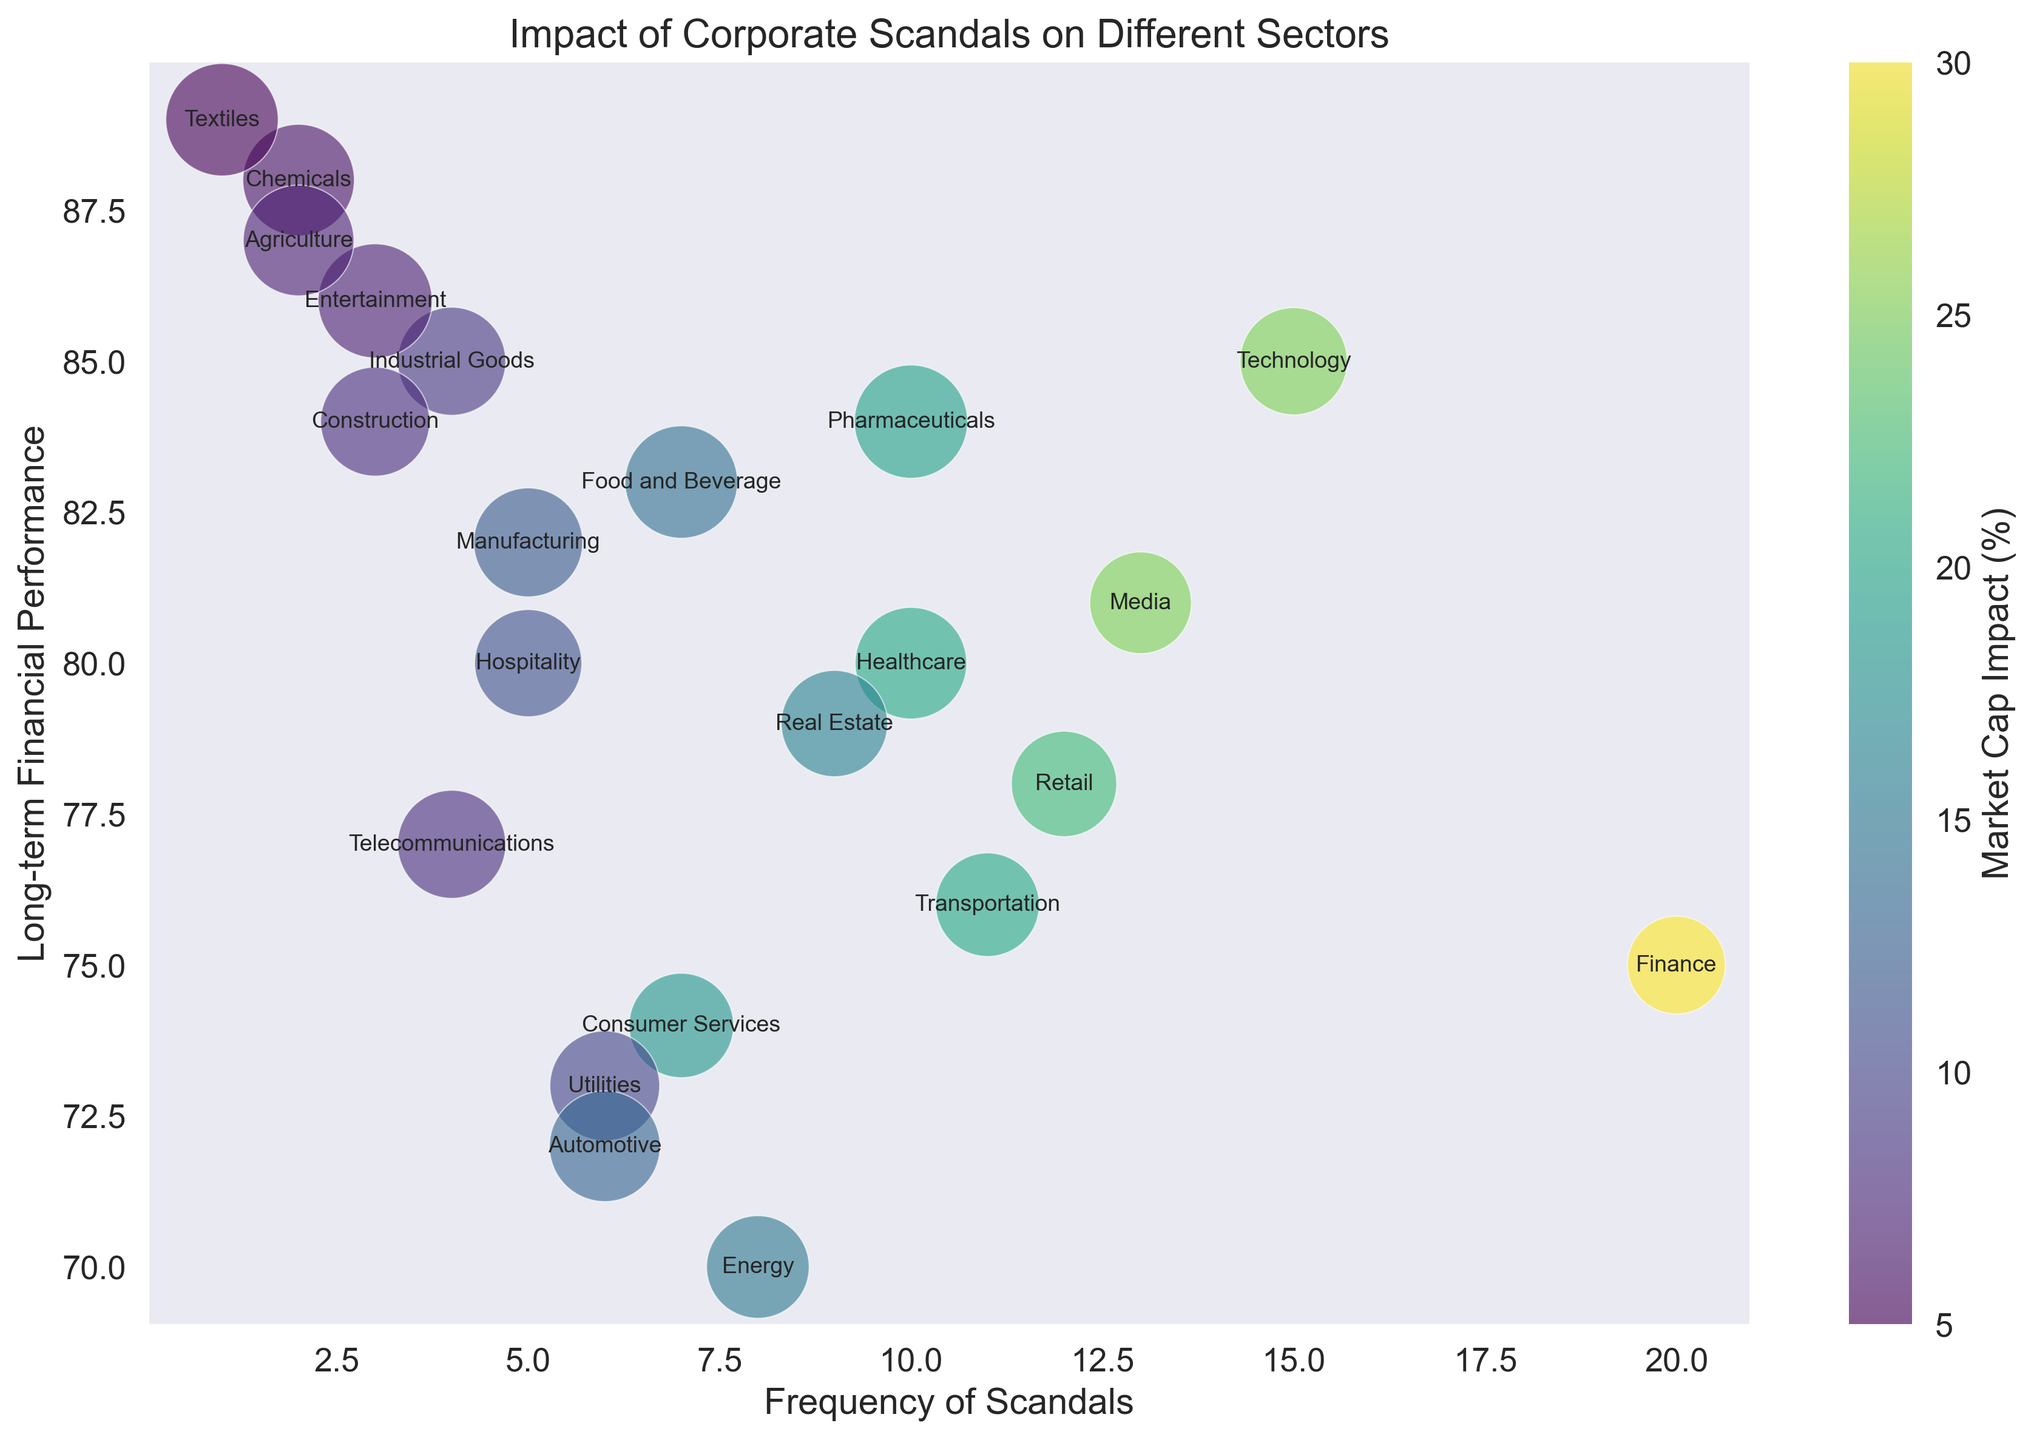Which sector has the highest frequency of scandals? By examining the x-axis representing frequency, the sector with the highest number is Finance, which stands at 20 scandals.
Answer: Finance Which sector shows the least impact on market cap while having a significant frequency of scandals? Looking at the color intensity, which represents market cap impact, and the size of the bubble, the Technology sector has 15 scandals and a less intense color (25 on market cap impact) compared to others with similar frequencies.
Answer: Technology Which sector has the best long-term financial performance with fewer than 5 scandals? By checking the y-axis for long-term financial performance and the x-axis for frequency, Entertainment has the highest score (86) with only 3 scandals.
Answer: Entertainment How does the Healthcare sector's long-term financial performance compare to the Pharmaceuticals sector? The y-axis shows Healthcare with a performance of 80 and Pharmaceuticals at 84, indicating Pharmaceuticals has a better performance by 4 points.
Answer: Pharmaceuticals What is the average market cap impact for sectors with a reputation score above 60? Identify sectors with a reputation score above 60. These are Technology (25), Healthcare (20), Manufacturing (12), Pharmaceuticals (19), Food and Beverage (14), Textiles (5), and Industrial Goods (9). Calculating the average: (25+20+12+19+14+5+9)/7 = 14.857.
Answer: 14.857 Which sectors fall below a long-term performance score of 75 and what are their respective frequencies? Find sectors below 75 on the y-axis. These are Energy (8), Finance (20), Consumer Services (7), and Utilities (6).
Answer: Energy: 8, Finance: 20, Consumer Services: 7, Utilities: 6 Does a high reputation score correlate with fewer scandals? Compare the bubble sizes (representing reputation score) with the x-axis (frequency). For instance, Textiles (high reputation score of 66) has only 1 scandal, suggesting a correlation, but not conclusively for all sectors.
Answer: Mixed correlation Which sectors have both a market cap impact of 20 or less and a long-term performance of 80 or more? Look for sectors with the market cap impact ≤20 (color intensity) and a performance ≥80 (y-axis). These are Healthcare, Manufacturing, Real Estate, Pharmaceuticals, Media, Hospitality, Industrial Goods, Chemicals, Textiles, and Agriculture.
Answer: Healthcare, Manufacturing, Real Estate, Pharmaceuticals, Media, Hospitality, Industrial Goods, Chemicals, Textiles, Agriculture Compare the bubble sizes for Technology and Finance sectors, and what does this indicate about their reputation scores? The bubble size represents reputation score; Technology has a bigger bubble size (score 60) compared to Finance (score 50), indicating higher reputational standing.
Answer: Technology has a higher reputation score 